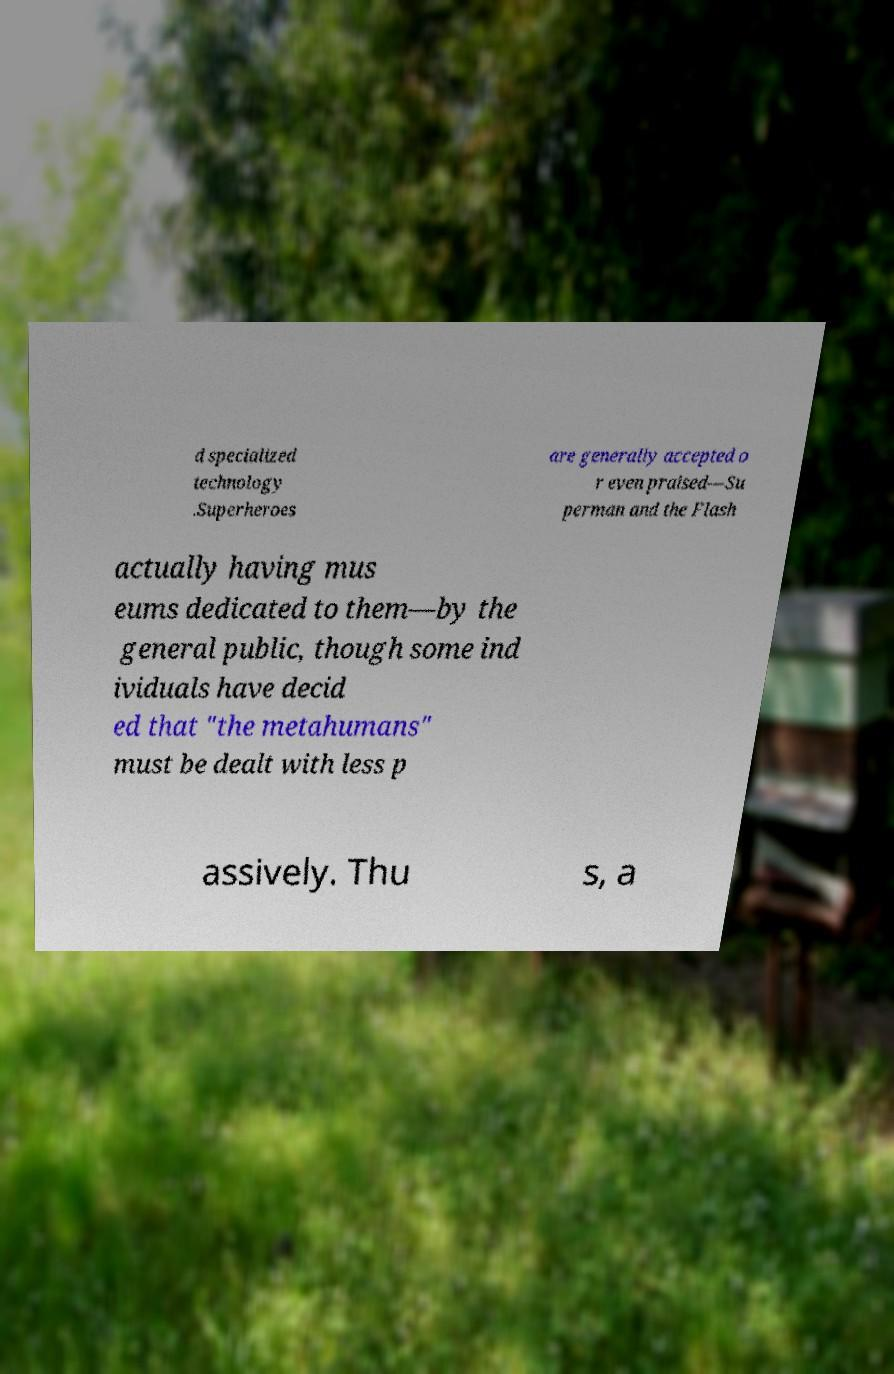Can you read and provide the text displayed in the image?This photo seems to have some interesting text. Can you extract and type it out for me? d specialized technology .Superheroes are generally accepted o r even praised—Su perman and the Flash actually having mus eums dedicated to them—by the general public, though some ind ividuals have decid ed that "the metahumans" must be dealt with less p assively. Thu s, a 